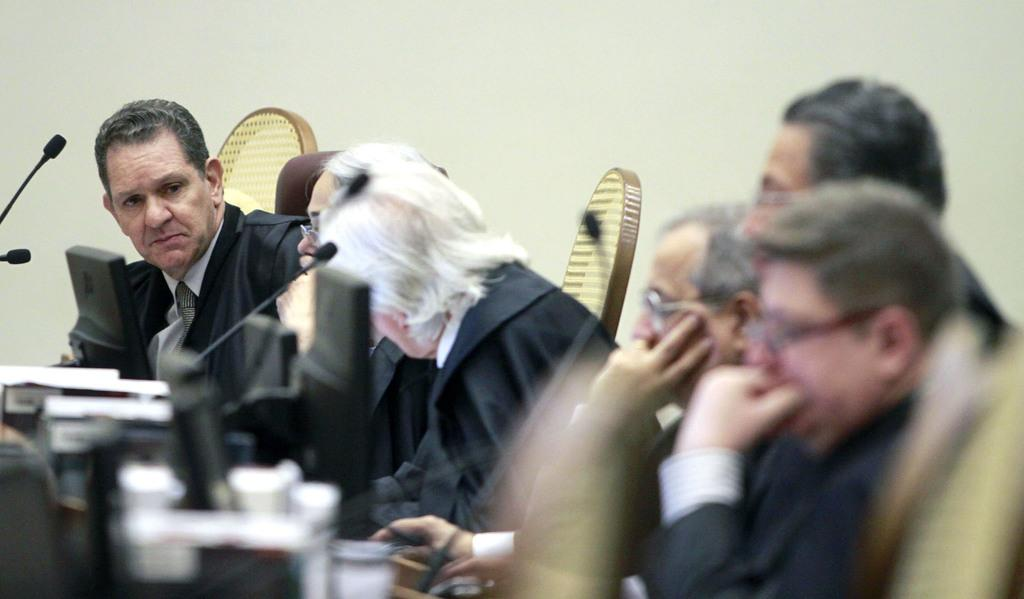What are the people in the image doing? The people in the image are sitting on chairs. Where are the chairs located in the image? The chairs are in the foreground area of the image. What objects are in front of the people? There are mics and monitors in front of the people. What type of wax can be seen melting on the chairs in the image? There is no wax present in the image; the chairs are occupied by people. 